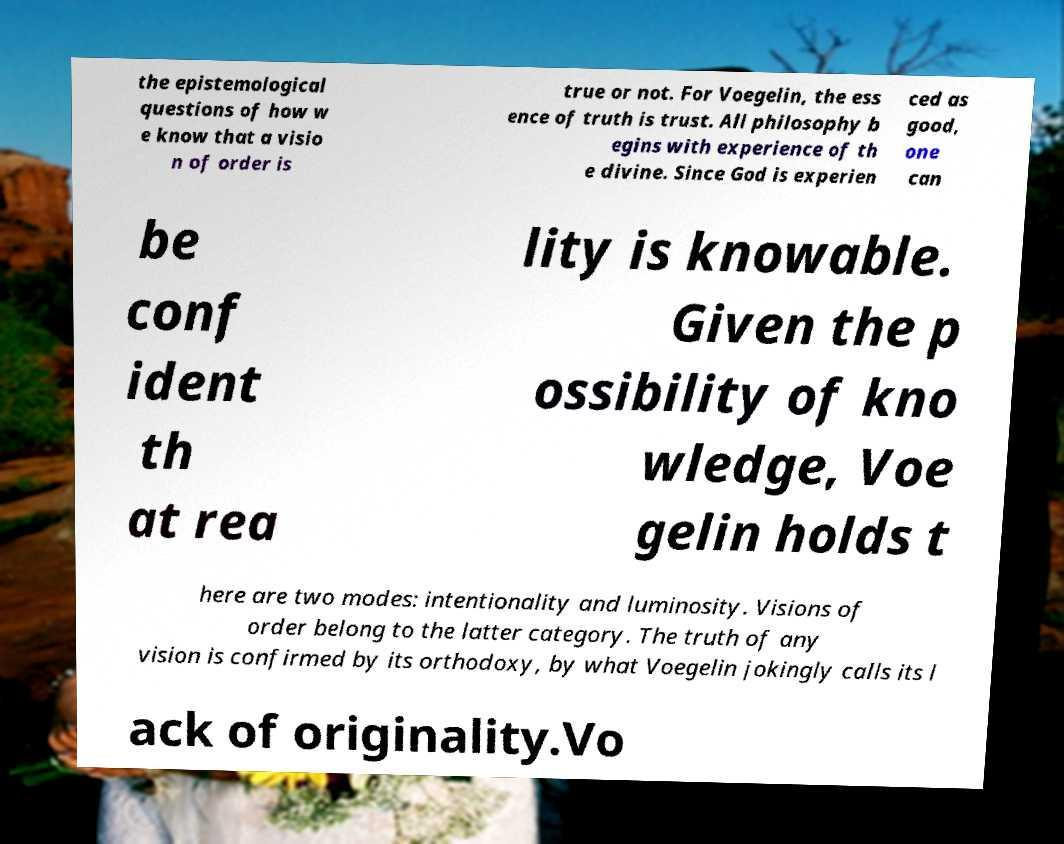Please read and relay the text visible in this image. What does it say? the epistemological questions of how w e know that a visio n of order is true or not. For Voegelin, the ess ence of truth is trust. All philosophy b egins with experience of th e divine. Since God is experien ced as good, one can be conf ident th at rea lity is knowable. Given the p ossibility of kno wledge, Voe gelin holds t here are two modes: intentionality and luminosity. Visions of order belong to the latter category. The truth of any vision is confirmed by its orthodoxy, by what Voegelin jokingly calls its l ack of originality.Vo 